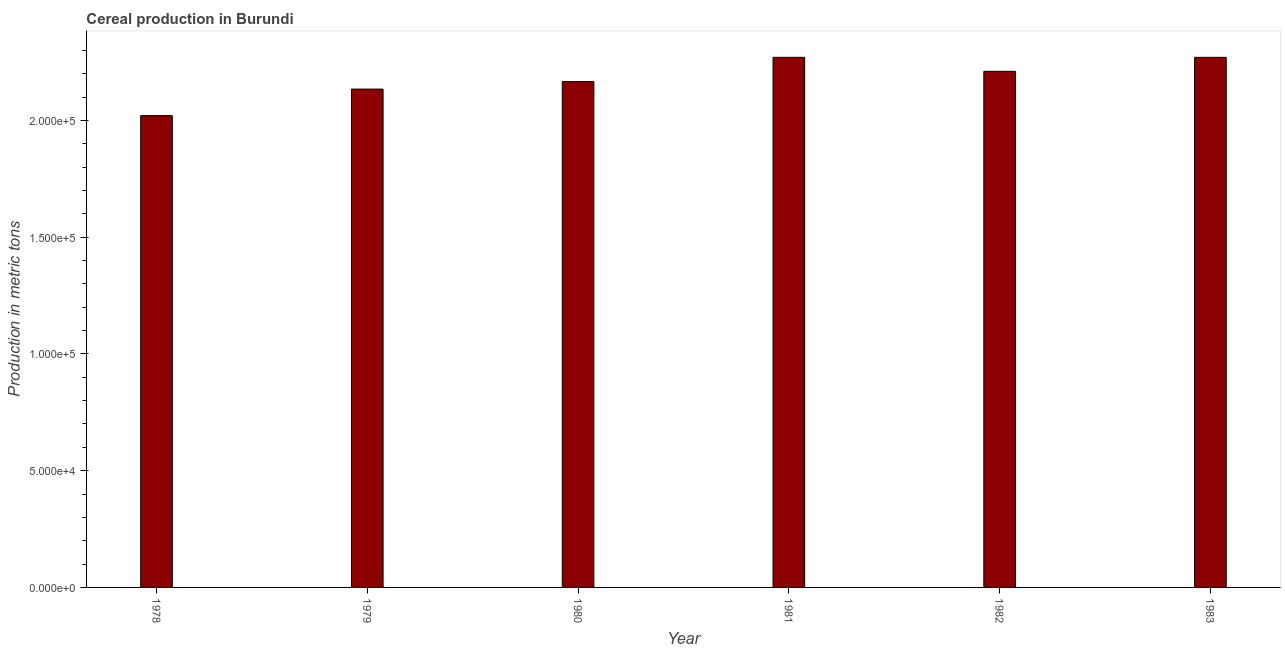Does the graph contain grids?
Ensure brevity in your answer.  No. What is the title of the graph?
Your answer should be compact. Cereal production in Burundi. What is the label or title of the Y-axis?
Your answer should be very brief. Production in metric tons. What is the cereal production in 1982?
Your response must be concise. 2.21e+05. Across all years, what is the maximum cereal production?
Your answer should be compact. 2.27e+05. Across all years, what is the minimum cereal production?
Ensure brevity in your answer.  2.02e+05. In which year was the cereal production maximum?
Ensure brevity in your answer.  1981. In which year was the cereal production minimum?
Provide a succinct answer. 1978. What is the sum of the cereal production?
Offer a very short reply. 1.31e+06. What is the difference between the cereal production in 1979 and 1983?
Offer a very short reply. -1.36e+04. What is the average cereal production per year?
Provide a short and direct response. 2.18e+05. What is the median cereal production?
Ensure brevity in your answer.  2.19e+05. In how many years, is the cereal production greater than 220000 metric tons?
Your response must be concise. 3. What is the ratio of the cereal production in 1978 to that in 1983?
Give a very brief answer. 0.89. Is the difference between the cereal production in 1978 and 1980 greater than the difference between any two years?
Your response must be concise. No. What is the difference between the highest and the second highest cereal production?
Ensure brevity in your answer.  0. What is the difference between the highest and the lowest cereal production?
Your response must be concise. 2.50e+04. Are all the bars in the graph horizontal?
Your response must be concise. No. How many years are there in the graph?
Provide a succinct answer. 6. Are the values on the major ticks of Y-axis written in scientific E-notation?
Your response must be concise. Yes. What is the Production in metric tons of 1978?
Keep it short and to the point. 2.02e+05. What is the Production in metric tons in 1979?
Provide a short and direct response. 2.13e+05. What is the Production in metric tons of 1980?
Offer a very short reply. 2.17e+05. What is the Production in metric tons in 1981?
Your response must be concise. 2.27e+05. What is the Production in metric tons of 1982?
Offer a terse response. 2.21e+05. What is the Production in metric tons in 1983?
Offer a very short reply. 2.27e+05. What is the difference between the Production in metric tons in 1978 and 1979?
Make the answer very short. -1.14e+04. What is the difference between the Production in metric tons in 1978 and 1980?
Offer a terse response. -1.46e+04. What is the difference between the Production in metric tons in 1978 and 1981?
Make the answer very short. -2.50e+04. What is the difference between the Production in metric tons in 1978 and 1982?
Make the answer very short. -1.90e+04. What is the difference between the Production in metric tons in 1978 and 1983?
Keep it short and to the point. -2.50e+04. What is the difference between the Production in metric tons in 1979 and 1980?
Your answer should be compact. -3200. What is the difference between the Production in metric tons in 1979 and 1981?
Ensure brevity in your answer.  -1.36e+04. What is the difference between the Production in metric tons in 1979 and 1982?
Ensure brevity in your answer.  -7600. What is the difference between the Production in metric tons in 1979 and 1983?
Offer a very short reply. -1.36e+04. What is the difference between the Production in metric tons in 1980 and 1981?
Keep it short and to the point. -1.04e+04. What is the difference between the Production in metric tons in 1980 and 1982?
Offer a very short reply. -4400. What is the difference between the Production in metric tons in 1980 and 1983?
Your answer should be compact. -1.04e+04. What is the difference between the Production in metric tons in 1981 and 1982?
Make the answer very short. 6000. What is the difference between the Production in metric tons in 1982 and 1983?
Make the answer very short. -6000. What is the ratio of the Production in metric tons in 1978 to that in 1979?
Offer a terse response. 0.95. What is the ratio of the Production in metric tons in 1978 to that in 1980?
Make the answer very short. 0.93. What is the ratio of the Production in metric tons in 1978 to that in 1981?
Ensure brevity in your answer.  0.89. What is the ratio of the Production in metric tons in 1978 to that in 1982?
Offer a terse response. 0.91. What is the ratio of the Production in metric tons in 1978 to that in 1983?
Ensure brevity in your answer.  0.89. What is the ratio of the Production in metric tons in 1979 to that in 1982?
Offer a terse response. 0.97. What is the ratio of the Production in metric tons in 1980 to that in 1981?
Ensure brevity in your answer.  0.95. What is the ratio of the Production in metric tons in 1980 to that in 1983?
Offer a terse response. 0.95. What is the ratio of the Production in metric tons in 1982 to that in 1983?
Offer a terse response. 0.97. 